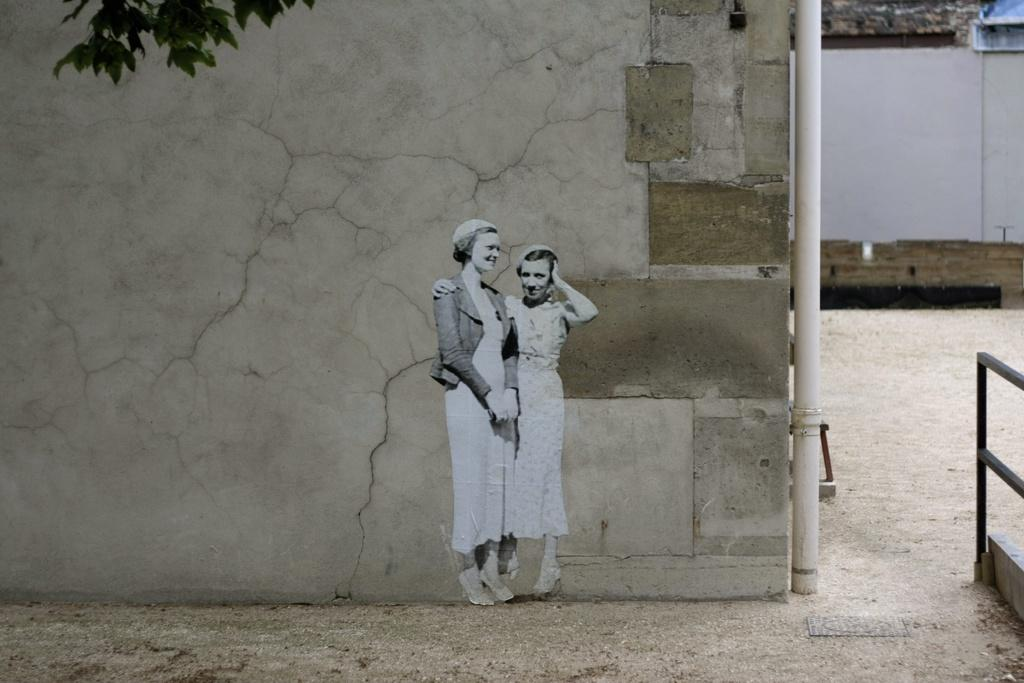How many women are present in the image? There are two women standing in the image. What is the surface on which the women are standing? The women are standing on the ground. What can be seen in the background of the image? There is a wall, a pipe, a building, and railing in the background of the image. Is there any vegetation visible in the image? Yes, there is a tree visible to the left top of the image. What is the caption written on the image? There is no caption present in the image. Can you tell me how many zebras are visible in the image? There are no zebras present in the image. 